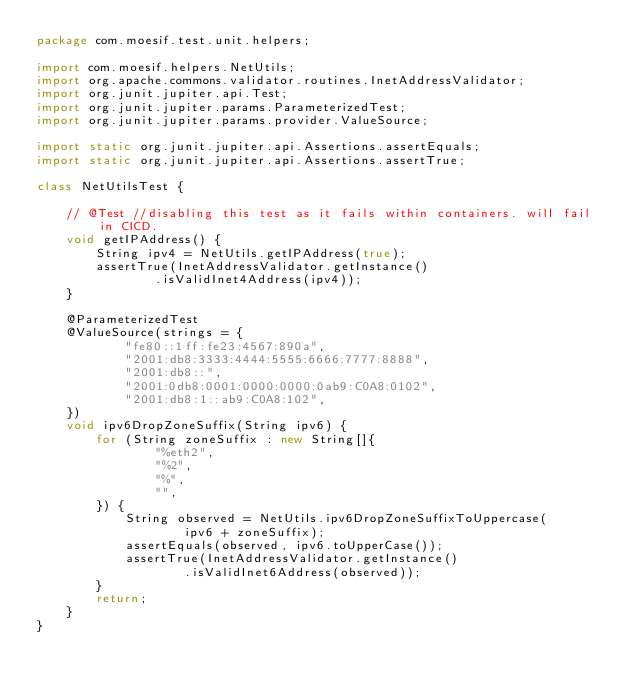<code> <loc_0><loc_0><loc_500><loc_500><_Java_>package com.moesif.test.unit.helpers;

import com.moesif.helpers.NetUtils;
import org.apache.commons.validator.routines.InetAddressValidator;
import org.junit.jupiter.api.Test;
import org.junit.jupiter.params.ParameterizedTest;
import org.junit.jupiter.params.provider.ValueSource;

import static org.junit.jupiter.api.Assertions.assertEquals;
import static org.junit.jupiter.api.Assertions.assertTrue;

class NetUtilsTest {

    // @Test //disabling this test as it fails within containers. will fail in CICD.
    void getIPAddress() {
        String ipv4 = NetUtils.getIPAddress(true);
        assertTrue(InetAddressValidator.getInstance()
                .isValidInet4Address(ipv4));
    }

    @ParameterizedTest
    @ValueSource(strings = {
            "fe80::1ff:fe23:4567:890a",
            "2001:db8:3333:4444:5555:6666:7777:8888",
            "2001:db8::",
            "2001:0db8:0001:0000:0000:0ab9:C0A8:0102",
            "2001:db8:1::ab9:C0A8:102",
    })
    void ipv6DropZoneSuffix(String ipv6) {
        for (String zoneSuffix : new String[]{
                "%eth2",
                "%2",
                "%",
                "",
        }) {
            String observed = NetUtils.ipv6DropZoneSuffixToUppercase(
                    ipv6 + zoneSuffix);
            assertEquals(observed, ipv6.toUpperCase());
            assertTrue(InetAddressValidator.getInstance()
                    .isValidInet6Address(observed));
        }
        return;
    }
}</code> 